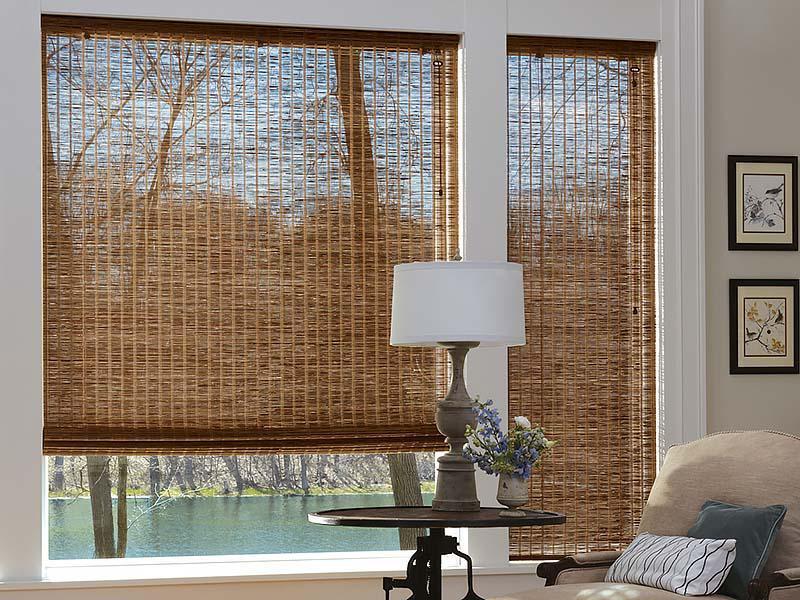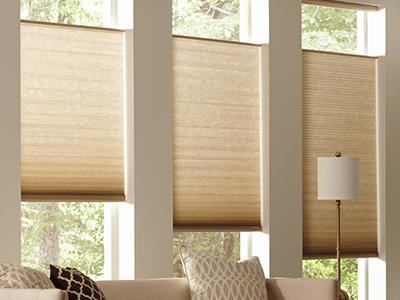The first image is the image on the left, the second image is the image on the right. Given the left and right images, does the statement "There are five shades." hold true? Answer yes or no. Yes. The first image is the image on the left, the second image is the image on the right. Considering the images on both sides, is "A couch is backed up against a row of windows in one of the images." valid? Answer yes or no. Yes. 